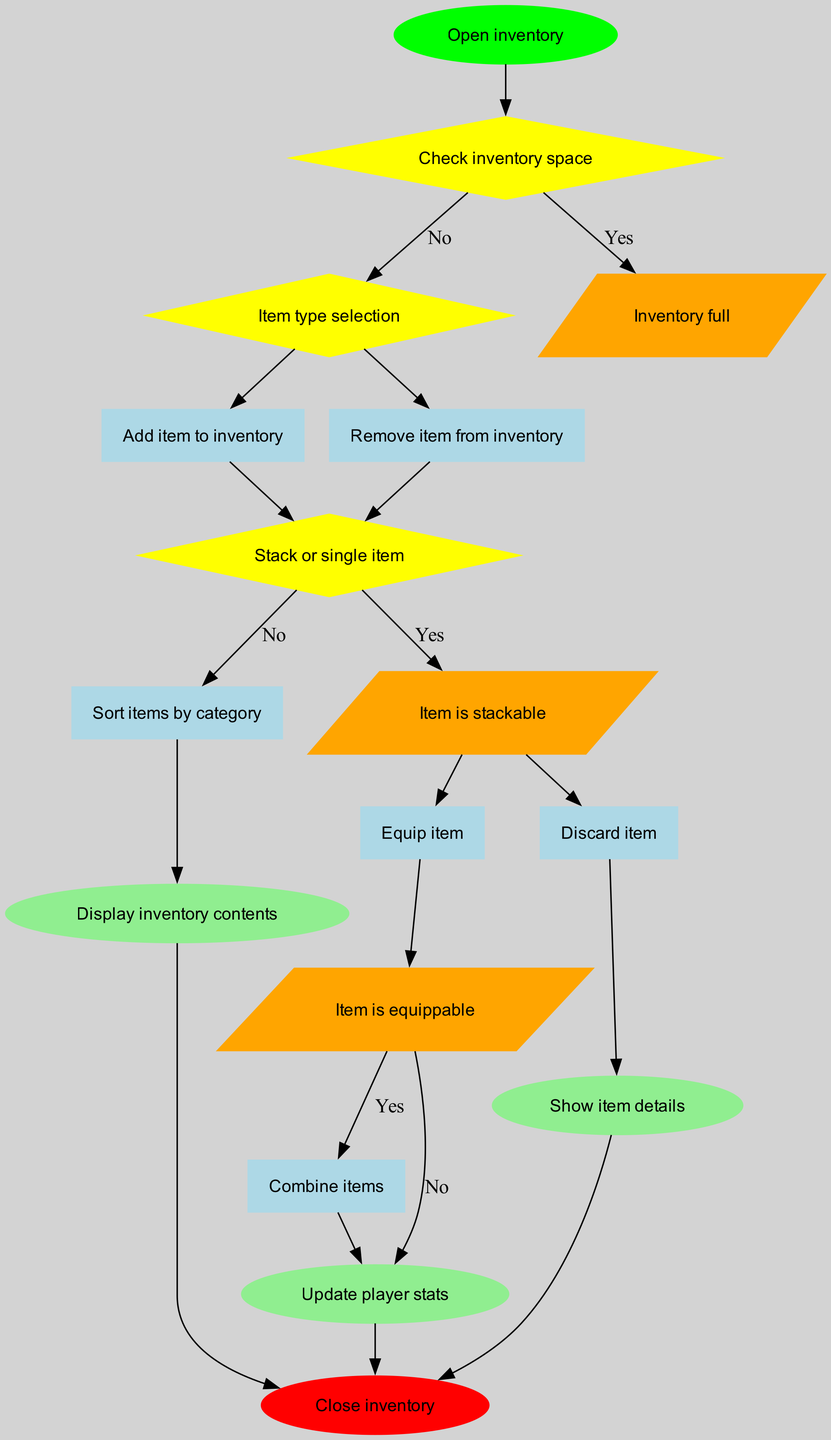What is the first action taken when opening the inventory? The flow chart indicates that the first action right after opening the inventory is to "Check inventory space."
Answer: Check inventory space How many decisions are present in the inventory management system? The diagram contains three decision nodes: "Check inventory space," "Item type selection," and "Stack or single item." Therefore, the total is three decisions.
Answer: 3 What happens if the inventory is full? If the condition "Inventory full" is met, the flow leads to a decision where the player cannot add items but can instead choose to discard an item or sort items by category. Therefore, the action is "Discard item" or "Sort items by category."
Answer: Discard item / Sort items by category Which action is taken if an item is equippable? Once the flow reaches the condition "Item is equippable" and it evaluates to "Yes," the action taken is to "Equip item."
Answer: Equip item What does the output "Update player stats" signify? The output "Update player stats" occurs after combining items, meaning when an item is stacked and the player stats need to reflect that change, this output is executed to ensure the player's stats are accurate based on the current items in inventory.
Answer: Update player stats What is the result of selecting a stackable item? When an item is selected that is stackable, and the condition is "Yes," it leads to the action "Combine items," which stacks the selected items together within the inventory.
Answer: Combine items Which is the last action in the flow? The flow ends with the action "Close inventory," which indicates that after completing all necessary actions, the player will exit the inventory management system.
Answer: Close inventory What are the two outputs that can occur after equipping an item? After equipping an item, the following outputs can occur: "Display inventory contents" and "Show item details," as both actions help in visualizing the current status of inventory after the action has been taken.
Answer: Display inventory contents / Show item details 